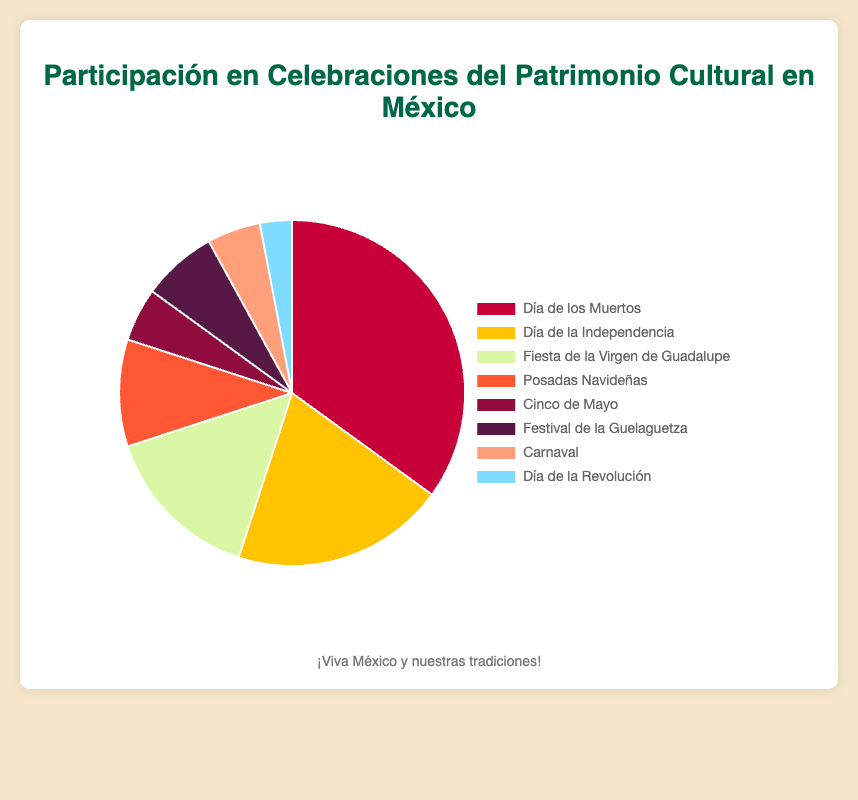Which event has the highest participation percentage? The 'Día de los Muertos' segment is visually the largest, indicating it has the highest participation percentage.
Answer: Día de los Muertos Which two events have equal participation percentages? Both 'Cinco de Mayo' and 'Carnival' segments appear equally small with the same participation percentage.
Answer: Cinco de Mayo and Carnival What is the total participation percentage for 'Independence Day' and 'Virgen de Guadalupe Feast'? 'Independence Day' has 20% and 'Virgen de Guadalupe Feast' has 15%. Summing them up: 20% + 15% = 35%
Answer: 35% Which event has a participation percentage half of 'Día de los Muertos'? 'Día de los Muertos' has 35%, so half of this is 35% / 2 = 17.5%. None of the exact segments show 17.5%, but the closest ones are 'Independence Day' (20%) and 'Virgen de Guadalupe Feast' (15%).
Answer: None Which event has the smallest participation percentage? The smallest segment belongs to 'Revolution Day', indicating the lowest participation percentage.
Answer: Revolution Day Which event has a higher participation percentage, 'Guelaguetza Festival' or 'Posadas Navideñas'? Visually, 'Posadas Navideñas' looks larger than 'Guelaguetza Festival'. Based on the data, 'Posadas Navideñas' has 10% and 'Guelaguetza Festival' has 7%.
Answer: Posadas Navideñas What is the combined participation percentage of 'Carnival' and 'Revolution Day'? 'Carnival' has 5% and 'Revolution Day' has 3%. Adding them together: 5% + 3% = 8%.
Answer: 8% Which color represents the 'Guelaguetza Festival' in the pie chart? The chart uses distinct colors for different events. 'Guelaguetza Festival' is indicated with purple (hex code not needed).
Answer: purple Compare the participation percentage of 'Posadas Navideñas' to 'Cinco de Mayo'. 'Posadas Navideñas' has 10% while 'Cinco de Mayo' has 5%. Thus, 'Posadas Navideñas' has a higher percentage.
Answer: Posadas Navideñas What is the average participation percentage for 'Carnival', 'Cinco de Mayo', and 'Revolution Day'? Their percentages are 5%, 5%, and 3% respectively. Sum them: 5% + 5% + 3% = 13%. Average: 13% / 3 = 4.33%.
Answer: 4.33% 